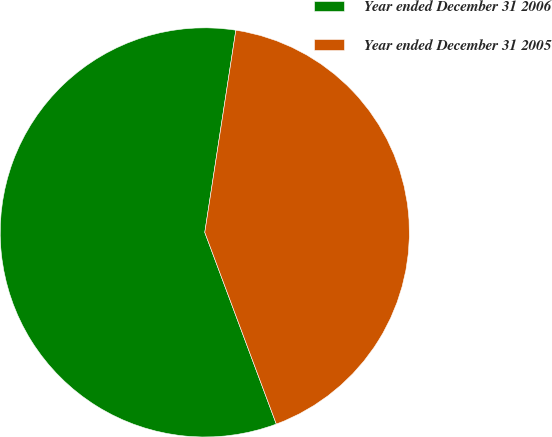<chart> <loc_0><loc_0><loc_500><loc_500><pie_chart><fcel>Year ended December 31 2006<fcel>Year ended December 31 2005<nl><fcel>58.11%<fcel>41.89%<nl></chart> 